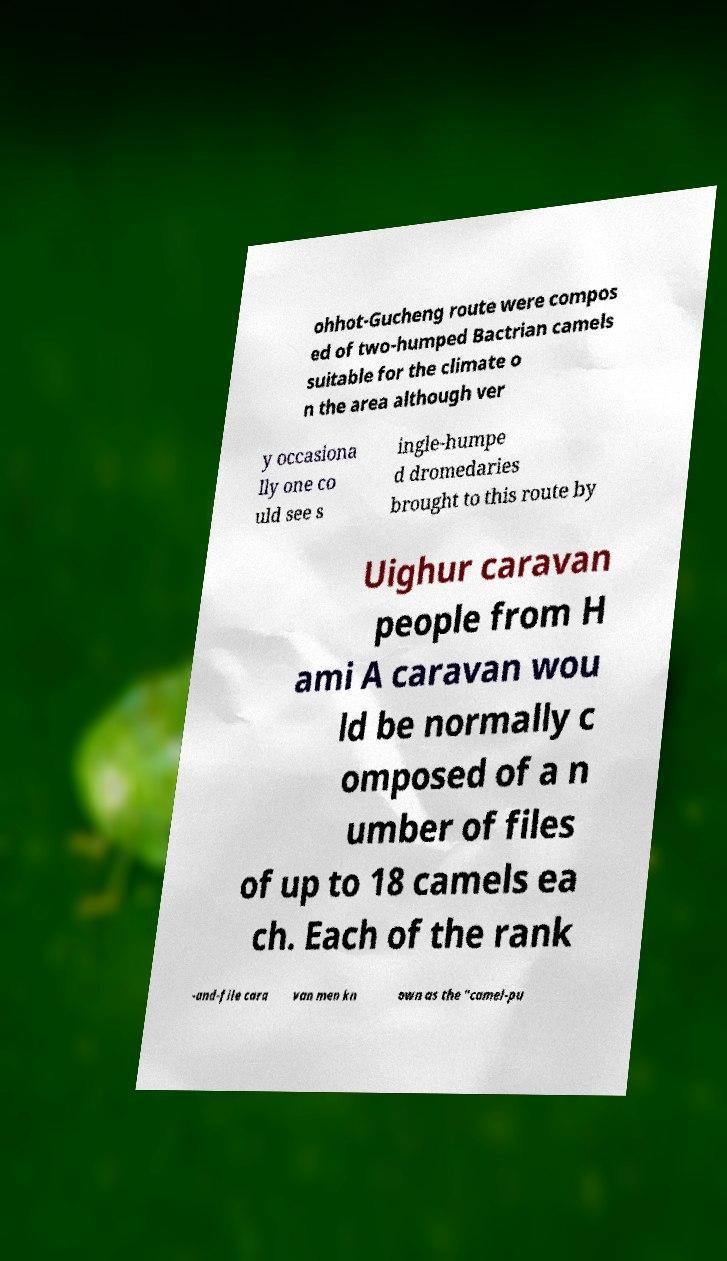Can you accurately transcribe the text from the provided image for me? ohhot-Gucheng route were compos ed of two-humped Bactrian camels suitable for the climate o n the area although ver y occasiona lly one co uld see s ingle-humpe d dromedaries brought to this route by Uighur caravan people from H ami A caravan wou ld be normally c omposed of a n umber of files of up to 18 camels ea ch. Each of the rank -and-file cara van men kn own as the "camel-pu 